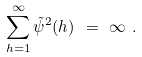<formula> <loc_0><loc_0><loc_500><loc_500>\sum _ { h = 1 } ^ { \infty } \tilde { \psi } ^ { 2 } ( h ) \ = \ \infty \ .</formula> 